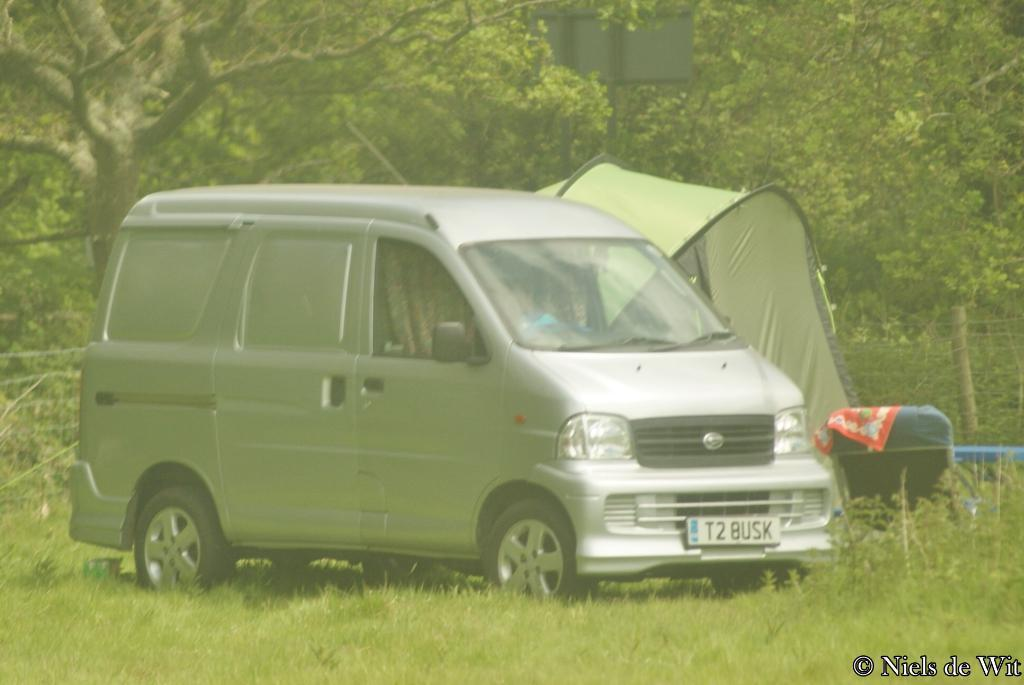<image>
Provide a brief description of the given image. A van parked in a field with the license plate T2BUSK written on the front. 